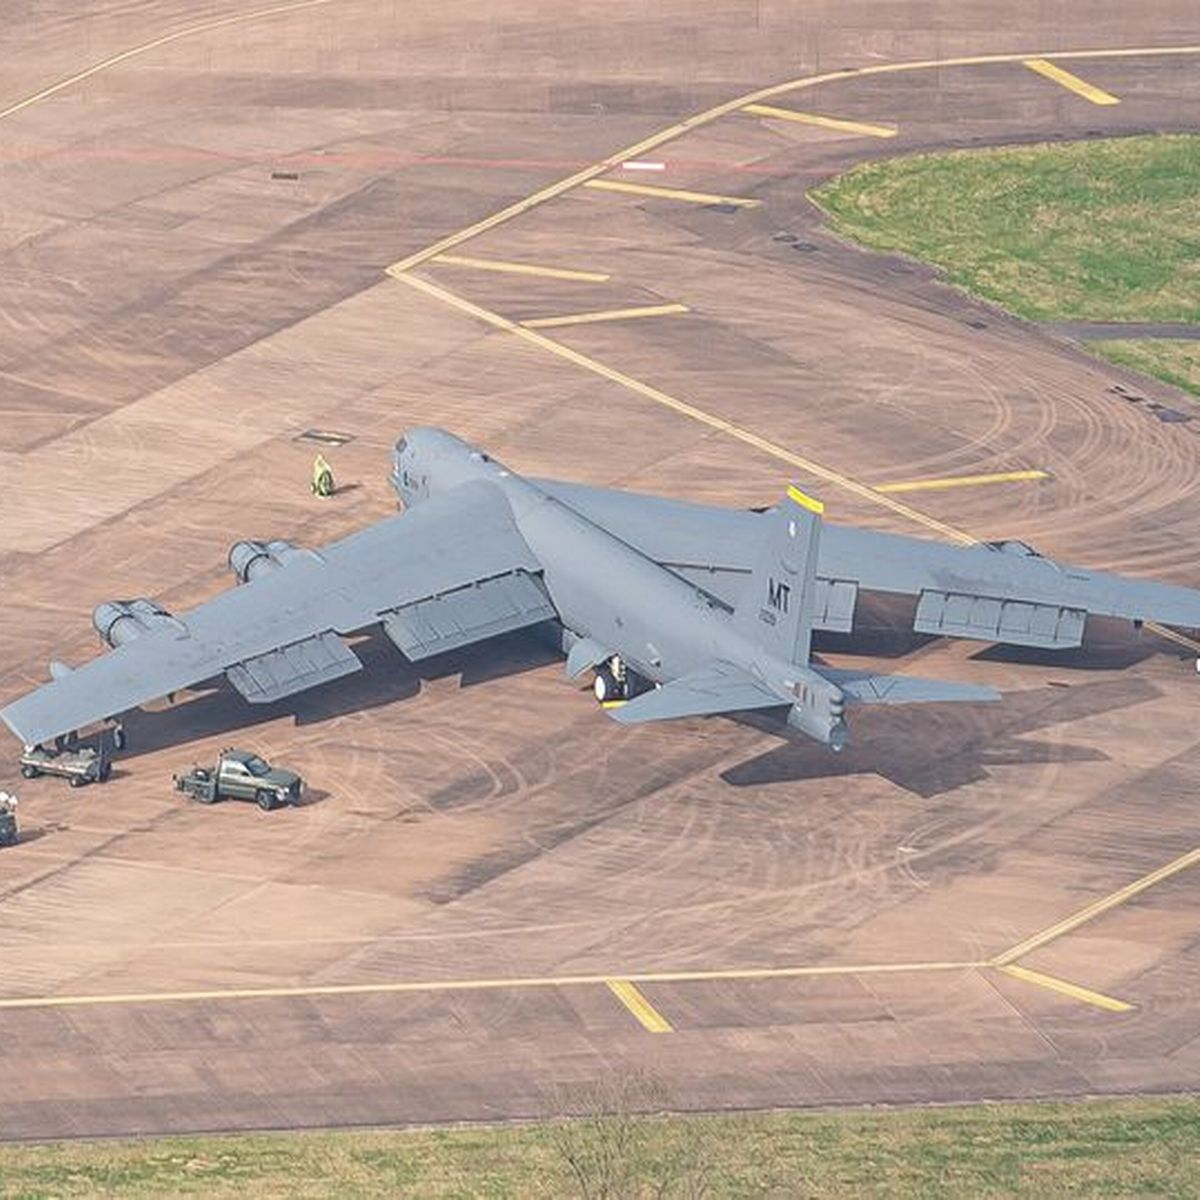Can you describe the features of the aeroplane in the image? Certainly! The aircraft in the image is a large military plane, characterized by its gray coloration, four-engine configuration, and distinctive swept-wing design. There are visible markings and insignia indicating its affiliation. The aircraft is positioned on a tarmac and appears to be ready for ground operations. 